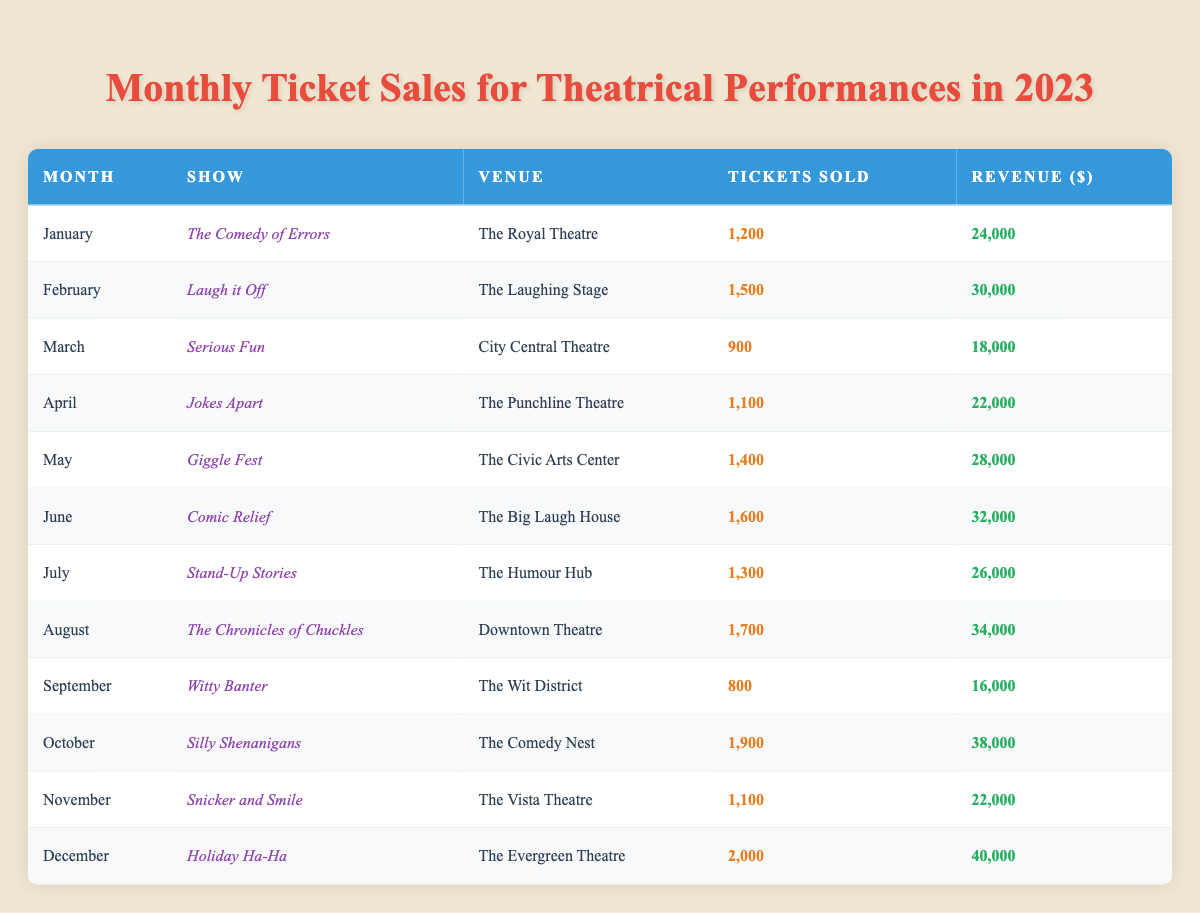What was the ticket sales for December? Referring to the table, in December, the show "Holiday Ha-Ha" sold 2,000 tickets.
Answer: 2,000 Which month had the highest revenue? By looking through the revenue column, October generated $38,000, the highest among all months listed.
Answer: October How many tickets were sold on average in the first half of the year (January to June)? The total tickets sold in January (1200), February (1500), March (900), April (1100), May (1400), and June (1600) amounts to 6,400. Dividing by 6 gives an average of 1,066.67.
Answer: 1,066.67 Did "Witty Banter" generate more or less than $20,000 in revenue? The revenue for "Witty Banter" in September is $16,000, which is less than $20,000.
Answer: Less What is the total revenue from all performances in 2023? Summing the revenue of all the months gives: $24,000 + $30,000 + $18,000 + $22,000 + $28,000 + $32,000 + $26,000 + $34,000 + $16,000 + $38,000 + $22,000 + $40,000 = $  360,000.
Answer: $360,000 In which month did "Comic Relief" take place? Looking at the table, "Comic Relief" was performed in June.
Answer: June How much more revenue did "The Chronicles of Chuckles" earn compared to "Comedy of Errors"? The revenue for "The Chronicles of Chuckles" in August is $34,000, and for "Comedy of Errors" in January is $24,000. The difference is $34,000 - $24,000 = $10,000.
Answer: $10,000 What percentage of total tickets sold for the year were in October? Total tickets sold is 16,500. Tickets sold in October is 1,900. The percentage is (1,900 / 16,500) * 100 = approximately 11.52%.
Answer: 11.52% Was the total number of tickets sold in November greater than in April? In November, 1,100 tickets were sold, and in April, 1,100 were sold as well. Hence, they are equal.
Answer: No Which show sold the fewest tickets? The show with the fewest tickets sold, according to the table, is "Witty Banter," with only 800 tickets sold in September.
Answer: Witty Banter 